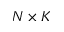Convert formula to latex. <formula><loc_0><loc_0><loc_500><loc_500>N \times K</formula> 